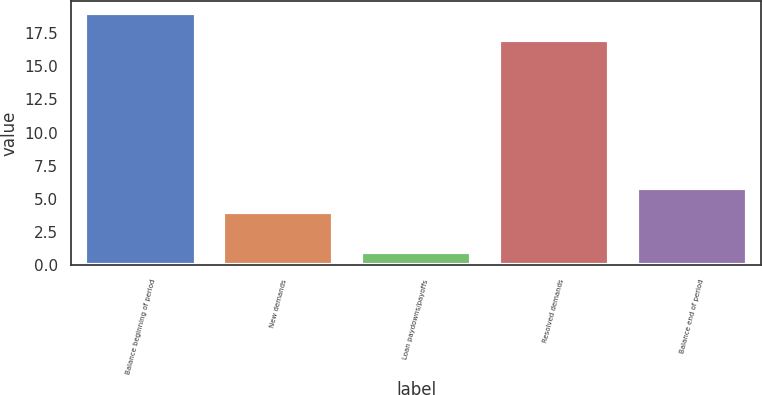Convert chart. <chart><loc_0><loc_0><loc_500><loc_500><bar_chart><fcel>Balance beginning of period<fcel>New demands<fcel>Loan paydowns/payoffs<fcel>Resolved demands<fcel>Balance end of period<nl><fcel>19<fcel>4<fcel>1<fcel>17<fcel>5.8<nl></chart> 